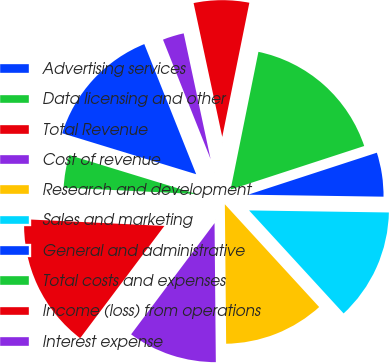Convert chart to OTSL. <chart><loc_0><loc_0><loc_500><loc_500><pie_chart><fcel>Advertising services<fcel>Data licensing and other<fcel>Total Revenue<fcel>Cost of revenue<fcel>Research and development<fcel>Sales and marketing<fcel>General and administrative<fcel>Total costs and expenses<fcel>Income (loss) from operations<fcel>Interest expense<nl><fcel>14.24%<fcel>3.96%<fcel>15.52%<fcel>10.39%<fcel>11.67%<fcel>12.95%<fcel>5.25%<fcel>16.81%<fcel>6.53%<fcel>2.68%<nl></chart> 